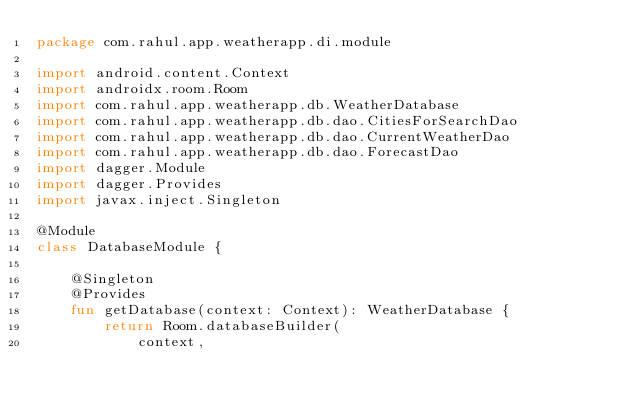Convert code to text. <code><loc_0><loc_0><loc_500><loc_500><_Kotlin_>package com.rahul.app.weatherapp.di.module

import android.content.Context
import androidx.room.Room
import com.rahul.app.weatherapp.db.WeatherDatabase
import com.rahul.app.weatherapp.db.dao.CitiesForSearchDao
import com.rahul.app.weatherapp.db.dao.CurrentWeatherDao
import com.rahul.app.weatherapp.db.dao.ForecastDao
import dagger.Module
import dagger.Provides
import javax.inject.Singleton

@Module
class DatabaseModule {

    @Singleton
    @Provides
    fun getDatabase(context: Context): WeatherDatabase {
        return Room.databaseBuilder(
            context,</code> 